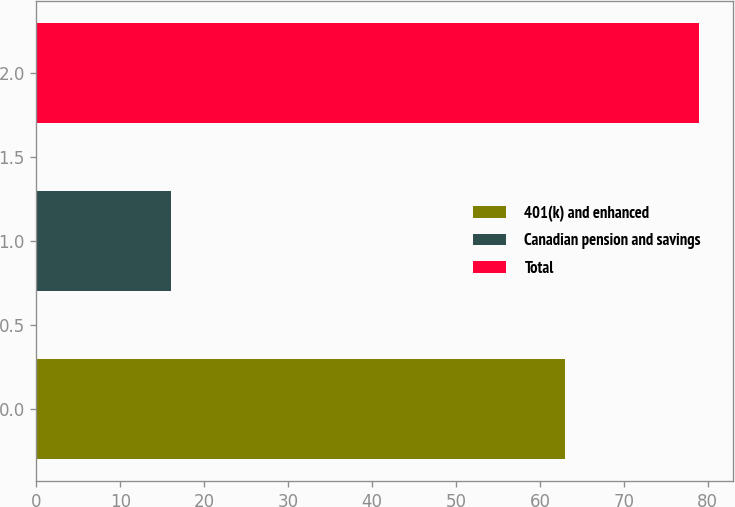Convert chart. <chart><loc_0><loc_0><loc_500><loc_500><bar_chart><fcel>401(k) and enhanced<fcel>Canadian pension and savings<fcel>Total<nl><fcel>63<fcel>16<fcel>79<nl></chart> 